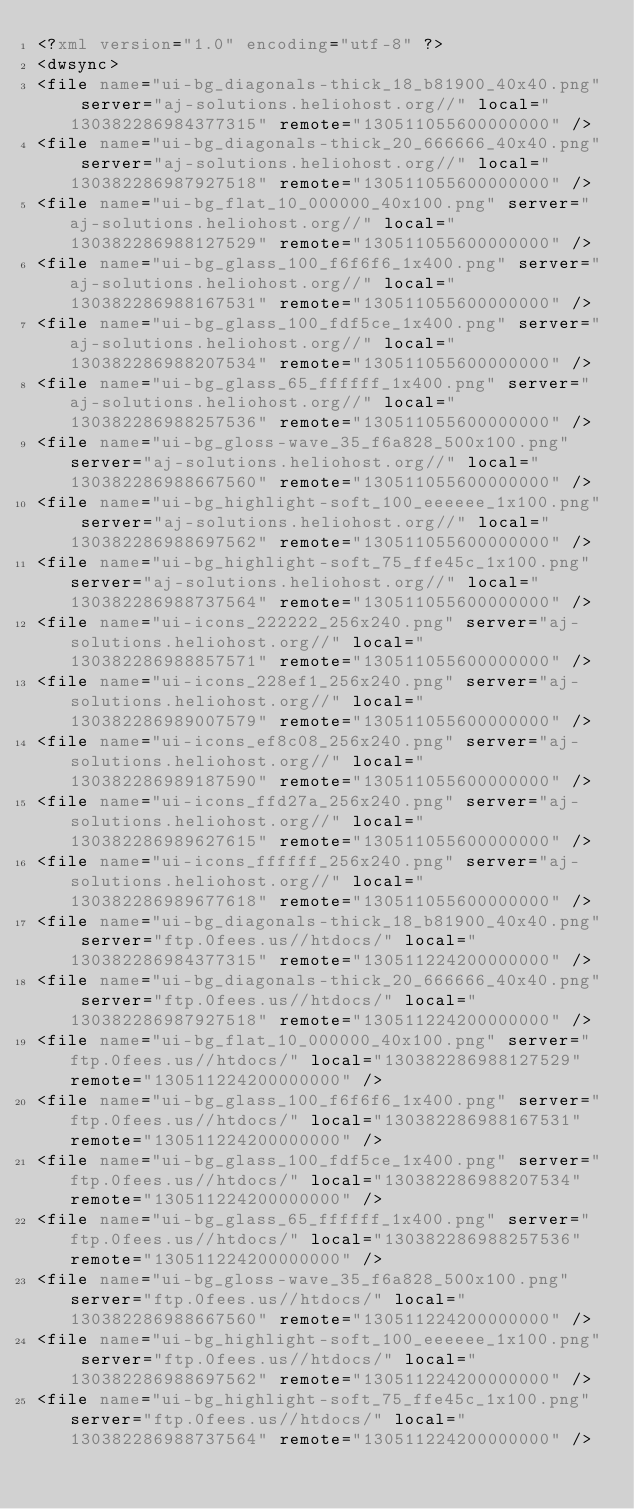<code> <loc_0><loc_0><loc_500><loc_500><_XML_><?xml version="1.0" encoding="utf-8" ?>
<dwsync>
<file name="ui-bg_diagonals-thick_18_b81900_40x40.png" server="aj-solutions.heliohost.org//" local="130382286984377315" remote="130511055600000000" />
<file name="ui-bg_diagonals-thick_20_666666_40x40.png" server="aj-solutions.heliohost.org//" local="130382286987927518" remote="130511055600000000" />
<file name="ui-bg_flat_10_000000_40x100.png" server="aj-solutions.heliohost.org//" local="130382286988127529" remote="130511055600000000" />
<file name="ui-bg_glass_100_f6f6f6_1x400.png" server="aj-solutions.heliohost.org//" local="130382286988167531" remote="130511055600000000" />
<file name="ui-bg_glass_100_fdf5ce_1x400.png" server="aj-solutions.heliohost.org//" local="130382286988207534" remote="130511055600000000" />
<file name="ui-bg_glass_65_ffffff_1x400.png" server="aj-solutions.heliohost.org//" local="130382286988257536" remote="130511055600000000" />
<file name="ui-bg_gloss-wave_35_f6a828_500x100.png" server="aj-solutions.heliohost.org//" local="130382286988667560" remote="130511055600000000" />
<file name="ui-bg_highlight-soft_100_eeeeee_1x100.png" server="aj-solutions.heliohost.org//" local="130382286988697562" remote="130511055600000000" />
<file name="ui-bg_highlight-soft_75_ffe45c_1x100.png" server="aj-solutions.heliohost.org//" local="130382286988737564" remote="130511055600000000" />
<file name="ui-icons_222222_256x240.png" server="aj-solutions.heliohost.org//" local="130382286988857571" remote="130511055600000000" />
<file name="ui-icons_228ef1_256x240.png" server="aj-solutions.heliohost.org//" local="130382286989007579" remote="130511055600000000" />
<file name="ui-icons_ef8c08_256x240.png" server="aj-solutions.heliohost.org//" local="130382286989187590" remote="130511055600000000" />
<file name="ui-icons_ffd27a_256x240.png" server="aj-solutions.heliohost.org//" local="130382286989627615" remote="130511055600000000" />
<file name="ui-icons_ffffff_256x240.png" server="aj-solutions.heliohost.org//" local="130382286989677618" remote="130511055600000000" />
<file name="ui-bg_diagonals-thick_18_b81900_40x40.png" server="ftp.0fees.us//htdocs/" local="130382286984377315" remote="130511224200000000" />
<file name="ui-bg_diagonals-thick_20_666666_40x40.png" server="ftp.0fees.us//htdocs/" local="130382286987927518" remote="130511224200000000" />
<file name="ui-bg_flat_10_000000_40x100.png" server="ftp.0fees.us//htdocs/" local="130382286988127529" remote="130511224200000000" />
<file name="ui-bg_glass_100_f6f6f6_1x400.png" server="ftp.0fees.us//htdocs/" local="130382286988167531" remote="130511224200000000" />
<file name="ui-bg_glass_100_fdf5ce_1x400.png" server="ftp.0fees.us//htdocs/" local="130382286988207534" remote="130511224200000000" />
<file name="ui-bg_glass_65_ffffff_1x400.png" server="ftp.0fees.us//htdocs/" local="130382286988257536" remote="130511224200000000" />
<file name="ui-bg_gloss-wave_35_f6a828_500x100.png" server="ftp.0fees.us//htdocs/" local="130382286988667560" remote="130511224200000000" />
<file name="ui-bg_highlight-soft_100_eeeeee_1x100.png" server="ftp.0fees.us//htdocs/" local="130382286988697562" remote="130511224200000000" />
<file name="ui-bg_highlight-soft_75_ffe45c_1x100.png" server="ftp.0fees.us//htdocs/" local="130382286988737564" remote="130511224200000000" /></code> 